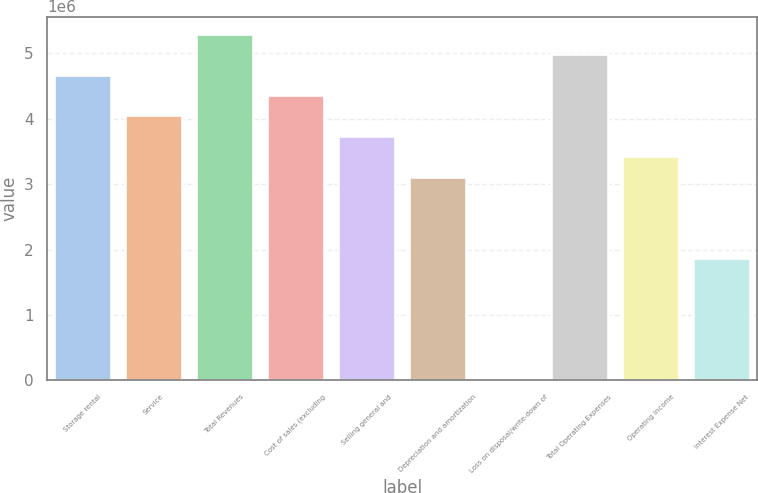Convert chart. <chart><loc_0><loc_0><loc_500><loc_500><bar_chart><fcel>Storage rental<fcel>Service<fcel>Total Revenues<fcel>Cost of sales (excluding<fcel>Selling general and<fcel>Depreciation and amortization<fcel>Loss on disposal/write-down of<fcel>Total Operating Expenses<fcel>Operating Income<fcel>Interest Expense Net<nl><fcel>4.67601e+06<fcel>4.05268e+06<fcel>5.29933e+06<fcel>4.36434e+06<fcel>3.74102e+06<fcel>3.11769e+06<fcel>1065<fcel>4.98767e+06<fcel>3.42936e+06<fcel>1.87104e+06<nl></chart> 